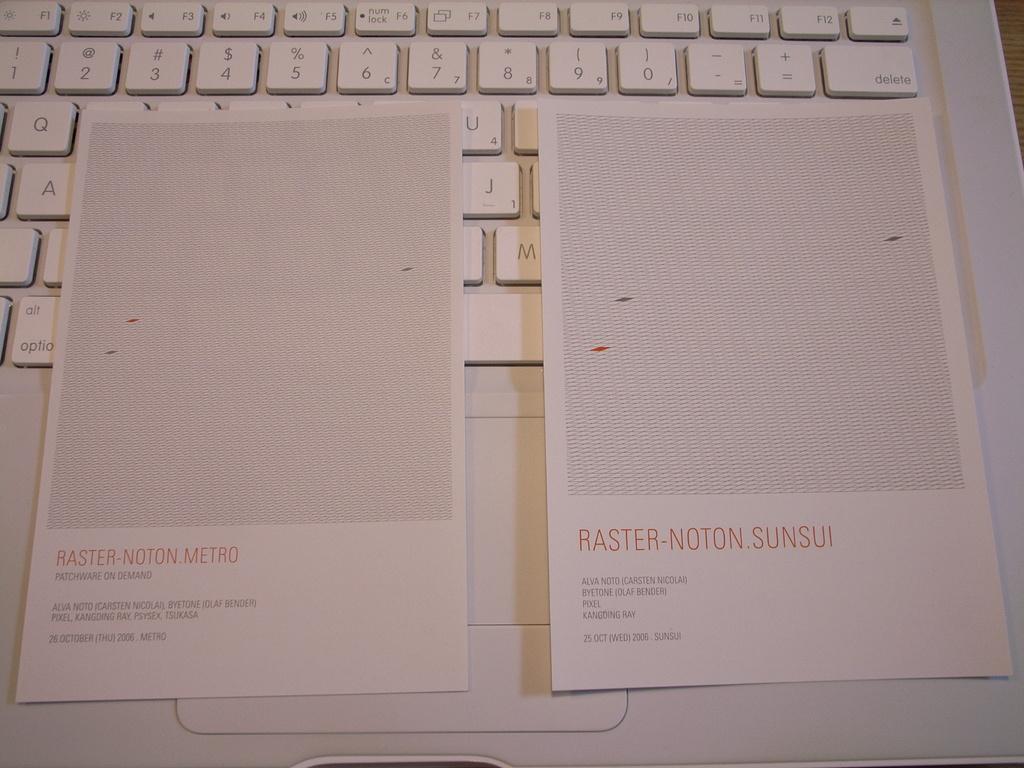What key is to the right of the equal sign on the keyboard?
Your answer should be very brief. Delete. 